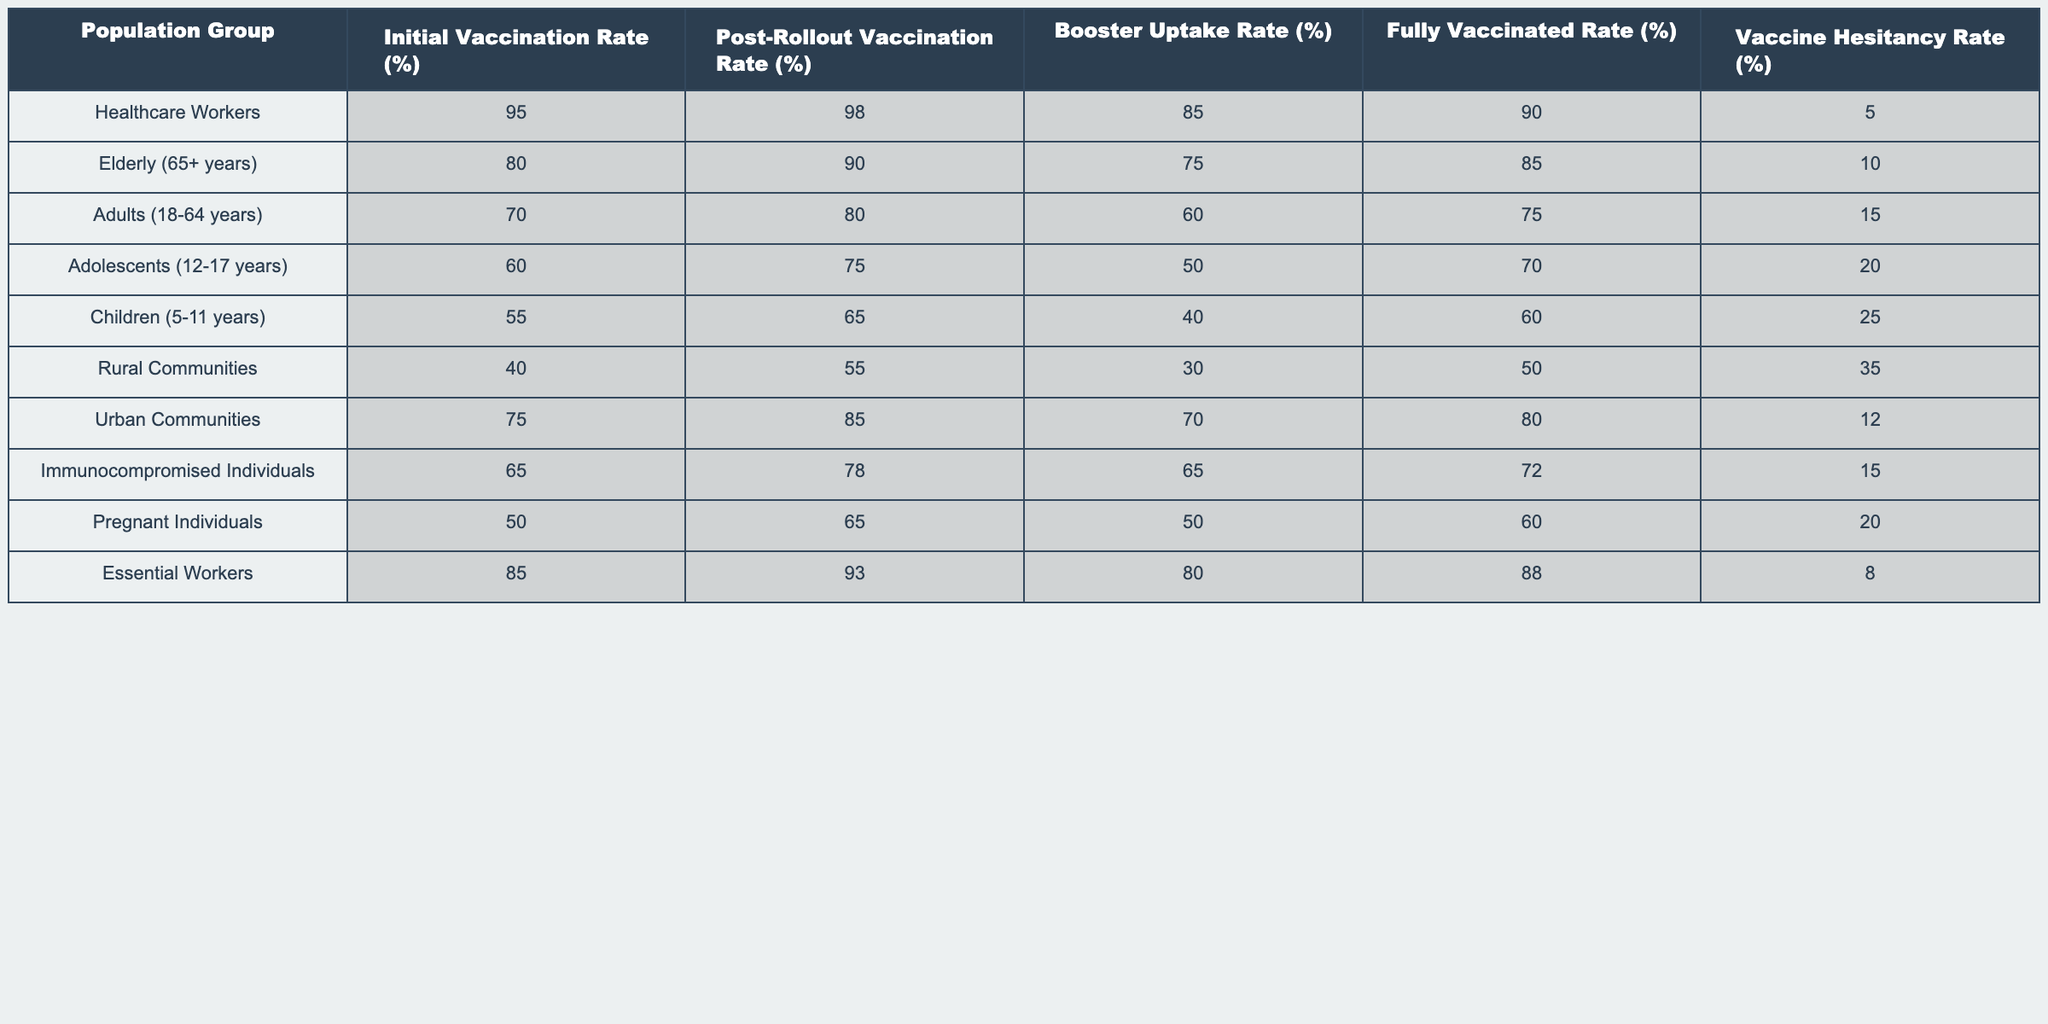What is the post-rollout vaccination rate for the elderly (65+ years) population group? From the table, the post-rollout vaccination rate for the elderly is directly listed under the relevant column. It shows a value of 90%.
Answer: 90% Which population group has the highest initial vaccination rate? By examining the initial vaccination rates across all groups, we see that healthcare workers have the highest rate at 95%.
Answer: 95% What is the average fully vaccinated rate across all population groups? To get the average, we sum the fully vaccinated rates: (90 + 85 + 75 + 70 + 60 + 50 + 80 + 72 + 60 + 88) = 830. There are 10 groups, so the average is 830/10 = 83.
Answer: 83% Is the vaccine hesitancy rate highest among rural communities? Looking at the vaccine hesitancy rates, rural communities have a rate of 35%, which is indeed the highest compared to the other groups.
Answer: Yes What is the difference between the post-rollout vaccination rate and the fully vaccinated rate for adolescents (12-17 years)? The post-rollout vaccination rate for adolescents is 75%, and the fully vaccinated rate is 70%. The difference is 75% - 70% = 5%.
Answer: 5% Which population group has the highest post-rollout vaccination rate among urban and rural communities? The post-rollout vaccination rates are 85% for urban communities and 55% for rural communities. Since 85% is greater than 55%, urban communities have the highest rate among them.
Answer: Urban Communities What percentage of healthcare workers opted for a booster after the vaccination rollout? The booster uptake rate specifically for healthcare workers is provided in the table as 85%.
Answer: 85% Which population group experienced the least increase from initial to post-rollout vaccination rate? To find the least increase, we calculate the differences: Healthcare Workers (3%), Elderly (10%), Adults (10%), Adolescents (15%), Children (10%), Rural Communities (15%), Urban Communities (10%), Immunocompromised (13%), Pregnant (15%), Essential Workers (8%). The smallest increase is 3% for healthcare workers.
Answer: Healthcare Workers How many population groups have a booster uptake rate less than 50%? By reviewing the booster uptake rates, we see those below 50% belong to children (40%) and rural communities (30%). Thus, there are two groups.
Answer: 2 What percentage of pregnant individuals are fully vaccinated after the vaccine rollout? Referring to the table, the fully vaccinated rate for pregnant individuals is listed as 60%.
Answer: 60% Is the fully vaccinated rate for essential workers higher than that for immunocompromised individuals? The fully vaccinated rate for essential workers is 88%, while for immunocompromised individuals, it is 72%. Since 88% is greater than 72%, the statement is true.
Answer: Yes 